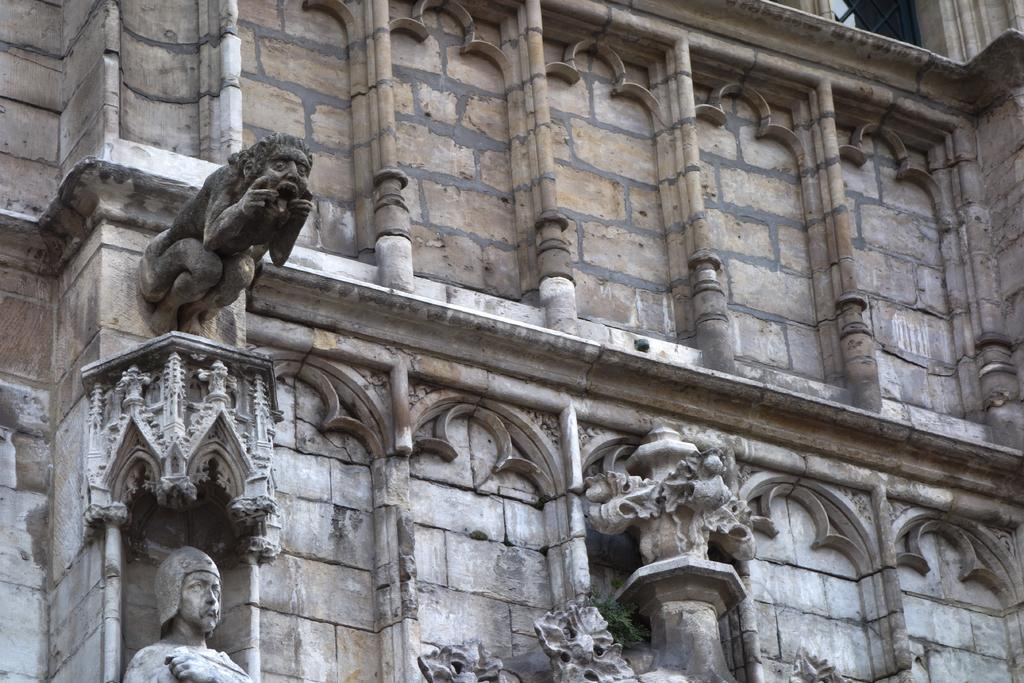What is the main subject of the image? The main subject of the image is a wall of a building. Are there any decorations or features on the wall? Yes, there are sculptures on the wall in the image. What is the doctor's opinion on the condition of the sculptures in the image? There is no doctor present in the image, and therefore no opinion on the condition of the sculptures can be provided. 